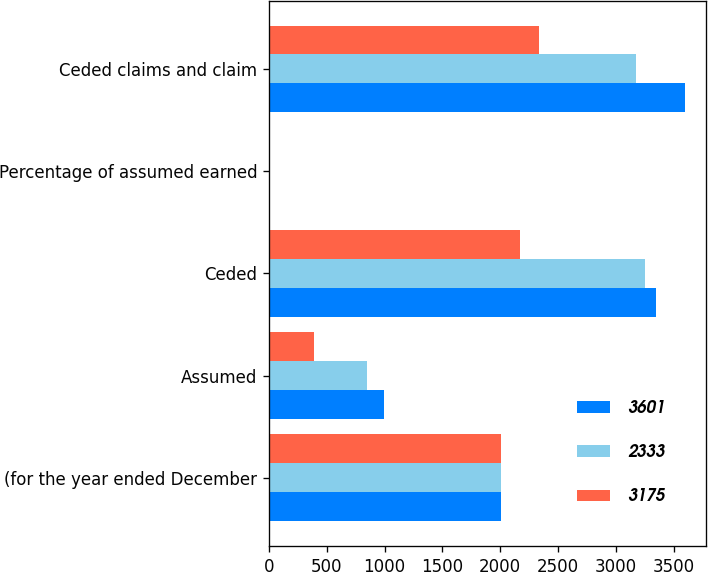Convert chart. <chart><loc_0><loc_0><loc_500><loc_500><stacked_bar_chart><ecel><fcel>(for the year ended December<fcel>Assumed<fcel>Ceded<fcel>Percentage of assumed earned<fcel>Ceded claims and claim<nl><fcel>3601<fcel>2005<fcel>995<fcel>3350<fcel>5.3<fcel>3601<nl><fcel>2333<fcel>2004<fcel>845<fcel>3247<fcel>5.3<fcel>3175<nl><fcel>3175<fcel>2003<fcel>393<fcel>2169<fcel>4<fcel>2333<nl></chart> 